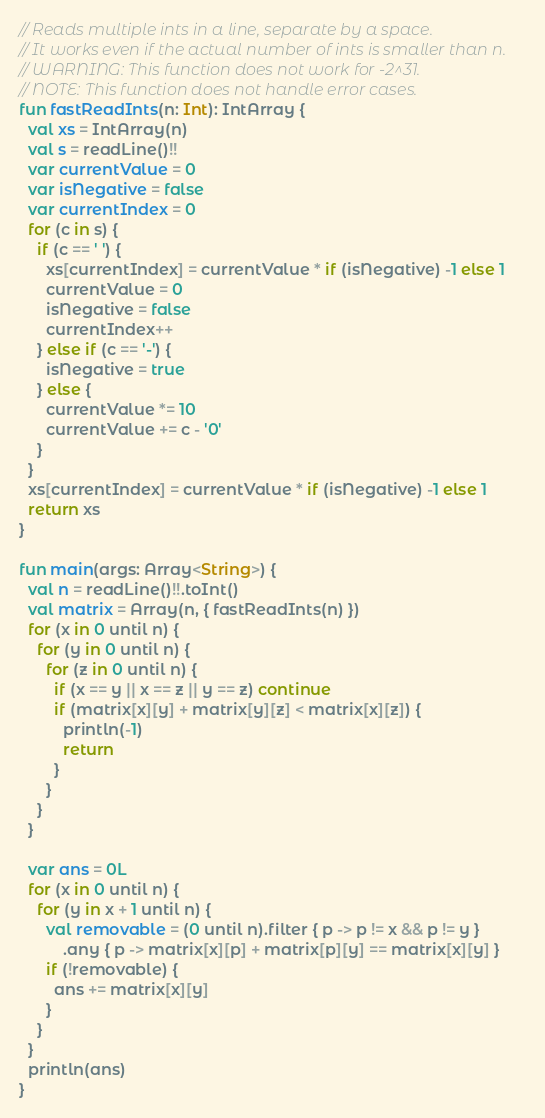Convert code to text. <code><loc_0><loc_0><loc_500><loc_500><_Kotlin_>// Reads multiple ints in a line, separate by a space.
// It works even if the actual number of ints is smaller than n.
// WARNING: This function does not work for -2^31.
// NOTE: This function does not handle error cases.
fun fastReadInts(n: Int): IntArray {
  val xs = IntArray(n)
  val s = readLine()!!
  var currentValue = 0
  var isNegative = false
  var currentIndex = 0
  for (c in s) {
    if (c == ' ') {
      xs[currentIndex] = currentValue * if (isNegative) -1 else 1
      currentValue = 0
      isNegative = false
      currentIndex++
    } else if (c == '-') {
      isNegative = true
    } else {
      currentValue *= 10
      currentValue += c - '0'
    }
  }
  xs[currentIndex] = currentValue * if (isNegative) -1 else 1
  return xs
}

fun main(args: Array<String>) {
  val n = readLine()!!.toInt()
  val matrix = Array(n, { fastReadInts(n) })
  for (x in 0 until n) {
    for (y in 0 until n) {
      for (z in 0 until n) {
        if (x == y || x == z || y == z) continue
        if (matrix[x][y] + matrix[y][z] < matrix[x][z]) {
          println(-1)
          return
        }
      }
    }
  }

  var ans = 0L
  for (x in 0 until n) {
    for (y in x + 1 until n) {
      val removable = (0 until n).filter { p -> p != x && p != y }
          .any { p -> matrix[x][p] + matrix[p][y] == matrix[x][y] }
      if (!removable) {
        ans += matrix[x][y]
      }
    }
  }
  println(ans)
}
</code> 